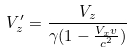<formula> <loc_0><loc_0><loc_500><loc_500>V _ { z } ^ { \prime } = \frac { V _ { z } } { \gamma ( 1 - \frac { V _ { x } v } { c ^ { 2 } } ) }</formula> 